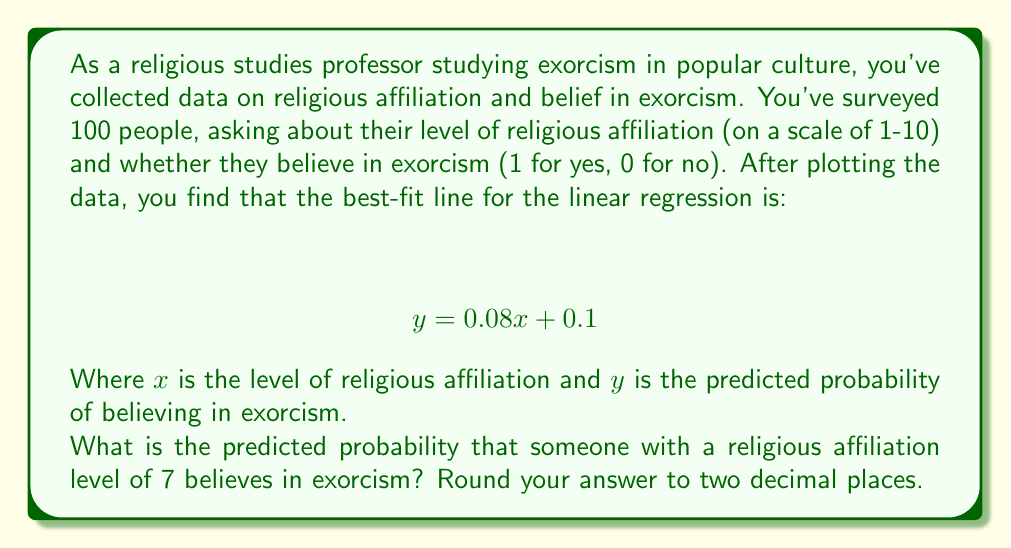Provide a solution to this math problem. To solve this problem, we need to use the given linear regression equation and substitute the value for $x$. Here's the step-by-step process:

1. The linear regression equation is:
   $$ y = 0.08x + 0.1 $$

2. We're asked about someone with a religious affiliation level of 7, so $x = 7$.

3. Substitute $x = 7$ into the equation:
   $$ y = 0.08(7) + 0.1 $$

4. Calculate:
   $$ y = 0.56 + 0.1 $$
   $$ y = 0.66 $$

5. Round to two decimal places:
   $$ y \approx 0.66 $$

This result represents the predicted probability that someone with a religious affiliation level of 7 believes in exorcism.
Answer: 0.66 